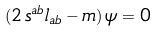Convert formula to latex. <formula><loc_0><loc_0><loc_500><loc_500>( 2 \, s ^ { a b } l _ { a b } - m ) \, \psi = 0</formula> 